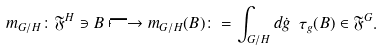<formula> <loc_0><loc_0><loc_500><loc_500>m _ { G / H } \colon \mathfrak { F } ^ { H } \ni B \longmapsto m _ { G / H } ( B ) \colon = \int _ { G / H } d \dot { g } \ \tau _ { g } ( B ) \in \mathfrak { F } ^ { G } \mathfrak { . }</formula> 